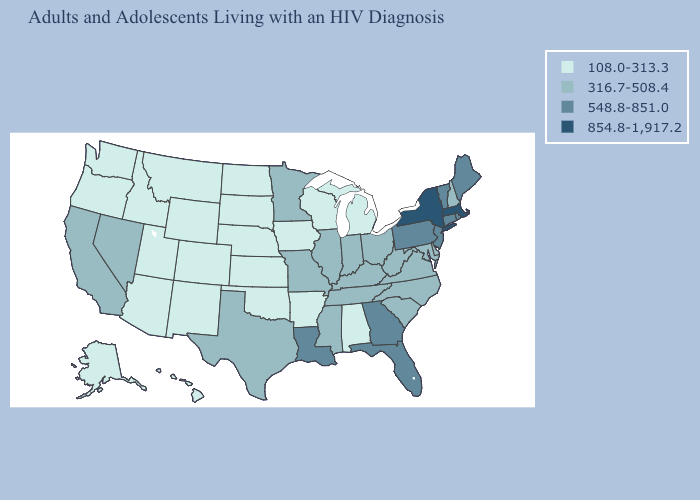What is the lowest value in the USA?
Be succinct. 108.0-313.3. Does Alabama have the lowest value in the South?
Answer briefly. Yes. Does Nebraska have a lower value than Pennsylvania?
Short answer required. Yes. What is the value of Nebraska?
Write a very short answer. 108.0-313.3. Does the first symbol in the legend represent the smallest category?
Write a very short answer. Yes. Is the legend a continuous bar?
Be succinct. No. What is the value of Florida?
Write a very short answer. 548.8-851.0. What is the value of Missouri?
Write a very short answer. 316.7-508.4. Does California have the lowest value in the USA?
Be succinct. No. What is the value of Washington?
Concise answer only. 108.0-313.3. Does Illinois have the lowest value in the USA?
Keep it brief. No. Does Colorado have the highest value in the West?
Be succinct. No. Name the states that have a value in the range 854.8-1,917.2?
Short answer required. Massachusetts, New York. What is the value of Georgia?
Give a very brief answer. 548.8-851.0. What is the value of Kansas?
Concise answer only. 108.0-313.3. 